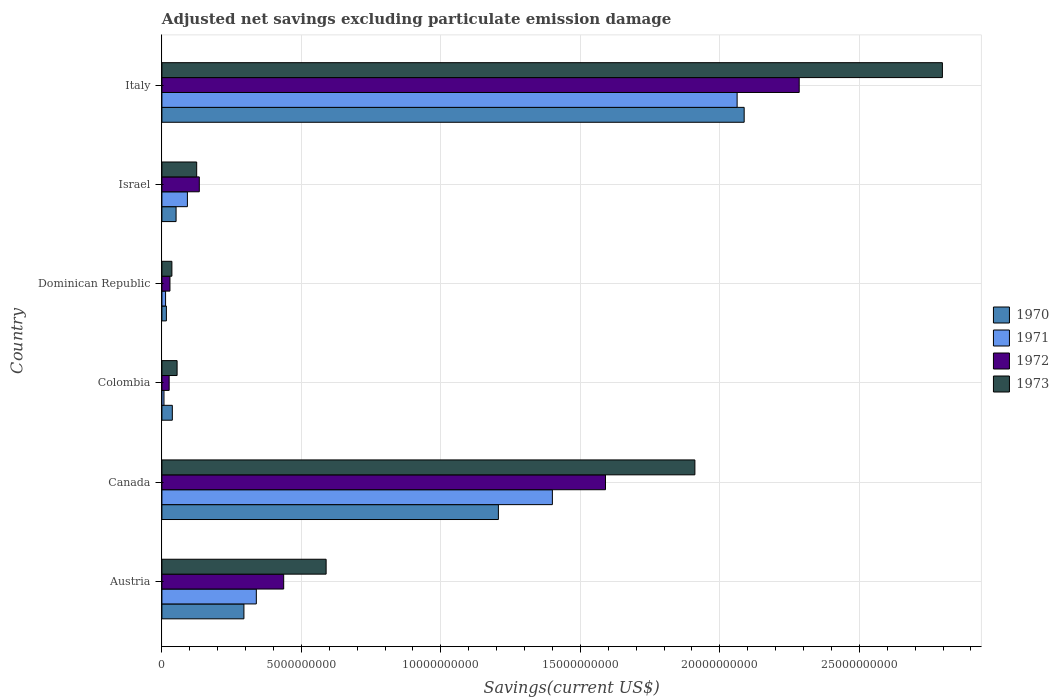How many groups of bars are there?
Provide a succinct answer. 6. Are the number of bars on each tick of the Y-axis equal?
Offer a very short reply. Yes. How many bars are there on the 6th tick from the bottom?
Ensure brevity in your answer.  4. What is the adjusted net savings in 1970 in Austria?
Offer a very short reply. 2.94e+09. Across all countries, what is the maximum adjusted net savings in 1970?
Offer a very short reply. 2.09e+1. Across all countries, what is the minimum adjusted net savings in 1973?
Keep it short and to the point. 3.58e+08. In which country was the adjusted net savings in 1970 minimum?
Your response must be concise. Dominican Republic. What is the total adjusted net savings in 1973 in the graph?
Your response must be concise. 5.51e+1. What is the difference between the adjusted net savings in 1971 in Austria and that in Israel?
Offer a terse response. 2.47e+09. What is the difference between the adjusted net savings in 1970 in Colombia and the adjusted net savings in 1972 in Canada?
Offer a terse response. -1.55e+1. What is the average adjusted net savings in 1972 per country?
Make the answer very short. 7.50e+09. What is the difference between the adjusted net savings in 1971 and adjusted net savings in 1972 in Israel?
Your answer should be very brief. -4.27e+08. In how many countries, is the adjusted net savings in 1972 greater than 15000000000 US$?
Offer a very short reply. 2. What is the ratio of the adjusted net savings in 1970 in Canada to that in Israel?
Make the answer very short. 23.75. What is the difference between the highest and the second highest adjusted net savings in 1973?
Offer a terse response. 8.87e+09. What is the difference between the highest and the lowest adjusted net savings in 1971?
Offer a very short reply. 2.05e+1. Is it the case that in every country, the sum of the adjusted net savings in 1970 and adjusted net savings in 1973 is greater than the sum of adjusted net savings in 1972 and adjusted net savings in 1971?
Provide a short and direct response. No. What does the 2nd bar from the top in Dominican Republic represents?
Provide a short and direct response. 1972. What does the 1st bar from the bottom in Colombia represents?
Give a very brief answer. 1970. Is it the case that in every country, the sum of the adjusted net savings in 1973 and adjusted net savings in 1972 is greater than the adjusted net savings in 1970?
Provide a succinct answer. Yes. Are all the bars in the graph horizontal?
Offer a very short reply. Yes. How many countries are there in the graph?
Provide a short and direct response. 6. What is the difference between two consecutive major ticks on the X-axis?
Your response must be concise. 5.00e+09. Does the graph contain any zero values?
Make the answer very short. No. Where does the legend appear in the graph?
Your answer should be very brief. Center right. What is the title of the graph?
Keep it short and to the point. Adjusted net savings excluding particulate emission damage. What is the label or title of the X-axis?
Your answer should be very brief. Savings(current US$). What is the label or title of the Y-axis?
Your response must be concise. Country. What is the Savings(current US$) of 1970 in Austria?
Keep it short and to the point. 2.94e+09. What is the Savings(current US$) in 1971 in Austria?
Ensure brevity in your answer.  3.38e+09. What is the Savings(current US$) in 1972 in Austria?
Provide a succinct answer. 4.37e+09. What is the Savings(current US$) in 1973 in Austria?
Your answer should be very brief. 5.89e+09. What is the Savings(current US$) of 1970 in Canada?
Offer a terse response. 1.21e+1. What is the Savings(current US$) in 1971 in Canada?
Offer a very short reply. 1.40e+1. What is the Savings(current US$) of 1972 in Canada?
Your response must be concise. 1.59e+1. What is the Savings(current US$) in 1973 in Canada?
Your response must be concise. 1.91e+1. What is the Savings(current US$) of 1970 in Colombia?
Ensure brevity in your answer.  3.74e+08. What is the Savings(current US$) in 1971 in Colombia?
Provide a succinct answer. 7.46e+07. What is the Savings(current US$) in 1972 in Colombia?
Your answer should be very brief. 2.60e+08. What is the Savings(current US$) of 1973 in Colombia?
Provide a succinct answer. 5.45e+08. What is the Savings(current US$) of 1970 in Dominican Republic?
Keep it short and to the point. 1.61e+08. What is the Savings(current US$) in 1971 in Dominican Republic?
Provide a short and direct response. 1.32e+08. What is the Savings(current US$) in 1972 in Dominican Republic?
Your answer should be very brief. 2.89e+08. What is the Savings(current US$) of 1973 in Dominican Republic?
Offer a very short reply. 3.58e+08. What is the Savings(current US$) of 1970 in Israel?
Offer a terse response. 5.08e+08. What is the Savings(current US$) in 1971 in Israel?
Offer a terse response. 9.14e+08. What is the Savings(current US$) of 1972 in Israel?
Your answer should be very brief. 1.34e+09. What is the Savings(current US$) of 1973 in Israel?
Your response must be concise. 1.25e+09. What is the Savings(current US$) in 1970 in Italy?
Your answer should be compact. 2.09e+1. What is the Savings(current US$) of 1971 in Italy?
Offer a terse response. 2.06e+1. What is the Savings(current US$) of 1972 in Italy?
Offer a terse response. 2.28e+1. What is the Savings(current US$) in 1973 in Italy?
Make the answer very short. 2.80e+1. Across all countries, what is the maximum Savings(current US$) of 1970?
Provide a succinct answer. 2.09e+1. Across all countries, what is the maximum Savings(current US$) in 1971?
Ensure brevity in your answer.  2.06e+1. Across all countries, what is the maximum Savings(current US$) of 1972?
Make the answer very short. 2.28e+1. Across all countries, what is the maximum Savings(current US$) of 1973?
Give a very brief answer. 2.80e+1. Across all countries, what is the minimum Savings(current US$) in 1970?
Offer a very short reply. 1.61e+08. Across all countries, what is the minimum Savings(current US$) in 1971?
Provide a short and direct response. 7.46e+07. Across all countries, what is the minimum Savings(current US$) in 1972?
Your answer should be very brief. 2.60e+08. Across all countries, what is the minimum Savings(current US$) of 1973?
Your answer should be compact. 3.58e+08. What is the total Savings(current US$) of 1970 in the graph?
Make the answer very short. 3.69e+1. What is the total Savings(current US$) in 1971 in the graph?
Offer a very short reply. 3.91e+1. What is the total Savings(current US$) of 1972 in the graph?
Offer a very short reply. 4.50e+1. What is the total Savings(current US$) in 1973 in the graph?
Ensure brevity in your answer.  5.51e+1. What is the difference between the Savings(current US$) in 1970 in Austria and that in Canada?
Offer a terse response. -9.12e+09. What is the difference between the Savings(current US$) of 1971 in Austria and that in Canada?
Make the answer very short. -1.06e+1. What is the difference between the Savings(current US$) of 1972 in Austria and that in Canada?
Provide a succinct answer. -1.15e+1. What is the difference between the Savings(current US$) of 1973 in Austria and that in Canada?
Your answer should be very brief. -1.32e+1. What is the difference between the Savings(current US$) of 1970 in Austria and that in Colombia?
Make the answer very short. 2.57e+09. What is the difference between the Savings(current US$) in 1971 in Austria and that in Colombia?
Provide a short and direct response. 3.31e+09. What is the difference between the Savings(current US$) of 1972 in Austria and that in Colombia?
Provide a succinct answer. 4.11e+09. What is the difference between the Savings(current US$) of 1973 in Austria and that in Colombia?
Provide a short and direct response. 5.34e+09. What is the difference between the Savings(current US$) in 1970 in Austria and that in Dominican Republic?
Offer a very short reply. 2.78e+09. What is the difference between the Savings(current US$) of 1971 in Austria and that in Dominican Republic?
Provide a succinct answer. 3.25e+09. What is the difference between the Savings(current US$) of 1972 in Austria and that in Dominican Republic?
Your response must be concise. 4.08e+09. What is the difference between the Savings(current US$) of 1973 in Austria and that in Dominican Republic?
Make the answer very short. 5.53e+09. What is the difference between the Savings(current US$) in 1970 in Austria and that in Israel?
Provide a succinct answer. 2.43e+09. What is the difference between the Savings(current US$) in 1971 in Austria and that in Israel?
Your answer should be very brief. 2.47e+09. What is the difference between the Savings(current US$) of 1972 in Austria and that in Israel?
Provide a short and direct response. 3.02e+09. What is the difference between the Savings(current US$) of 1973 in Austria and that in Israel?
Your response must be concise. 4.64e+09. What is the difference between the Savings(current US$) in 1970 in Austria and that in Italy?
Ensure brevity in your answer.  -1.79e+1. What is the difference between the Savings(current US$) of 1971 in Austria and that in Italy?
Keep it short and to the point. -1.72e+1. What is the difference between the Savings(current US$) in 1972 in Austria and that in Italy?
Offer a very short reply. -1.85e+1. What is the difference between the Savings(current US$) of 1973 in Austria and that in Italy?
Your response must be concise. -2.21e+1. What is the difference between the Savings(current US$) in 1970 in Canada and that in Colombia?
Offer a very short reply. 1.17e+1. What is the difference between the Savings(current US$) in 1971 in Canada and that in Colombia?
Keep it short and to the point. 1.39e+1. What is the difference between the Savings(current US$) of 1972 in Canada and that in Colombia?
Keep it short and to the point. 1.56e+1. What is the difference between the Savings(current US$) of 1973 in Canada and that in Colombia?
Offer a very short reply. 1.86e+1. What is the difference between the Savings(current US$) of 1970 in Canada and that in Dominican Republic?
Offer a very short reply. 1.19e+1. What is the difference between the Savings(current US$) in 1971 in Canada and that in Dominican Republic?
Provide a short and direct response. 1.39e+1. What is the difference between the Savings(current US$) of 1972 in Canada and that in Dominican Republic?
Ensure brevity in your answer.  1.56e+1. What is the difference between the Savings(current US$) of 1973 in Canada and that in Dominican Republic?
Keep it short and to the point. 1.87e+1. What is the difference between the Savings(current US$) of 1970 in Canada and that in Israel?
Your answer should be compact. 1.16e+1. What is the difference between the Savings(current US$) of 1971 in Canada and that in Israel?
Ensure brevity in your answer.  1.31e+1. What is the difference between the Savings(current US$) in 1972 in Canada and that in Israel?
Keep it short and to the point. 1.46e+1. What is the difference between the Savings(current US$) of 1973 in Canada and that in Israel?
Offer a terse response. 1.79e+1. What is the difference between the Savings(current US$) in 1970 in Canada and that in Italy?
Keep it short and to the point. -8.81e+09. What is the difference between the Savings(current US$) of 1971 in Canada and that in Italy?
Provide a succinct answer. -6.62e+09. What is the difference between the Savings(current US$) in 1972 in Canada and that in Italy?
Your answer should be very brief. -6.94e+09. What is the difference between the Savings(current US$) in 1973 in Canada and that in Italy?
Your answer should be very brief. -8.87e+09. What is the difference between the Savings(current US$) in 1970 in Colombia and that in Dominican Republic?
Your response must be concise. 2.13e+08. What is the difference between the Savings(current US$) in 1971 in Colombia and that in Dominican Republic?
Ensure brevity in your answer.  -5.69e+07. What is the difference between the Savings(current US$) in 1972 in Colombia and that in Dominican Republic?
Provide a succinct answer. -2.84e+07. What is the difference between the Savings(current US$) in 1973 in Colombia and that in Dominican Republic?
Provide a short and direct response. 1.87e+08. What is the difference between the Savings(current US$) in 1970 in Colombia and that in Israel?
Offer a terse response. -1.34e+08. What is the difference between the Savings(current US$) of 1971 in Colombia and that in Israel?
Offer a terse response. -8.40e+08. What is the difference between the Savings(current US$) in 1972 in Colombia and that in Israel?
Offer a terse response. -1.08e+09. What is the difference between the Savings(current US$) of 1973 in Colombia and that in Israel?
Offer a very short reply. -7.02e+08. What is the difference between the Savings(current US$) in 1970 in Colombia and that in Italy?
Your answer should be very brief. -2.05e+1. What is the difference between the Savings(current US$) in 1971 in Colombia and that in Italy?
Give a very brief answer. -2.05e+1. What is the difference between the Savings(current US$) of 1972 in Colombia and that in Italy?
Your answer should be compact. -2.26e+1. What is the difference between the Savings(current US$) in 1973 in Colombia and that in Italy?
Offer a terse response. -2.74e+1. What is the difference between the Savings(current US$) of 1970 in Dominican Republic and that in Israel?
Provide a short and direct response. -3.47e+08. What is the difference between the Savings(current US$) in 1971 in Dominican Republic and that in Israel?
Offer a terse response. -7.83e+08. What is the difference between the Savings(current US$) of 1972 in Dominican Republic and that in Israel?
Keep it short and to the point. -1.05e+09. What is the difference between the Savings(current US$) in 1973 in Dominican Republic and that in Israel?
Make the answer very short. -8.89e+08. What is the difference between the Savings(current US$) in 1970 in Dominican Republic and that in Italy?
Offer a very short reply. -2.07e+1. What is the difference between the Savings(current US$) in 1971 in Dominican Republic and that in Italy?
Ensure brevity in your answer.  -2.05e+1. What is the difference between the Savings(current US$) in 1972 in Dominican Republic and that in Italy?
Your answer should be compact. -2.26e+1. What is the difference between the Savings(current US$) in 1973 in Dominican Republic and that in Italy?
Offer a very short reply. -2.76e+1. What is the difference between the Savings(current US$) in 1970 in Israel and that in Italy?
Provide a succinct answer. -2.04e+1. What is the difference between the Savings(current US$) of 1971 in Israel and that in Italy?
Make the answer very short. -1.97e+1. What is the difference between the Savings(current US$) of 1972 in Israel and that in Italy?
Give a very brief answer. -2.15e+1. What is the difference between the Savings(current US$) of 1973 in Israel and that in Italy?
Your answer should be very brief. -2.67e+1. What is the difference between the Savings(current US$) in 1970 in Austria and the Savings(current US$) in 1971 in Canada?
Give a very brief answer. -1.11e+1. What is the difference between the Savings(current US$) in 1970 in Austria and the Savings(current US$) in 1972 in Canada?
Offer a terse response. -1.30e+1. What is the difference between the Savings(current US$) in 1970 in Austria and the Savings(current US$) in 1973 in Canada?
Make the answer very short. -1.62e+1. What is the difference between the Savings(current US$) of 1971 in Austria and the Savings(current US$) of 1972 in Canada?
Provide a succinct answer. -1.25e+1. What is the difference between the Savings(current US$) of 1971 in Austria and the Savings(current US$) of 1973 in Canada?
Provide a short and direct response. -1.57e+1. What is the difference between the Savings(current US$) of 1972 in Austria and the Savings(current US$) of 1973 in Canada?
Give a very brief answer. -1.47e+1. What is the difference between the Savings(current US$) in 1970 in Austria and the Savings(current US$) in 1971 in Colombia?
Keep it short and to the point. 2.87e+09. What is the difference between the Savings(current US$) in 1970 in Austria and the Savings(current US$) in 1972 in Colombia?
Give a very brief answer. 2.68e+09. What is the difference between the Savings(current US$) of 1970 in Austria and the Savings(current US$) of 1973 in Colombia?
Keep it short and to the point. 2.40e+09. What is the difference between the Savings(current US$) in 1971 in Austria and the Savings(current US$) in 1972 in Colombia?
Provide a short and direct response. 3.12e+09. What is the difference between the Savings(current US$) in 1971 in Austria and the Savings(current US$) in 1973 in Colombia?
Provide a short and direct response. 2.84e+09. What is the difference between the Savings(current US$) of 1972 in Austria and the Savings(current US$) of 1973 in Colombia?
Provide a short and direct response. 3.82e+09. What is the difference between the Savings(current US$) in 1970 in Austria and the Savings(current US$) in 1971 in Dominican Republic?
Offer a terse response. 2.81e+09. What is the difference between the Savings(current US$) in 1970 in Austria and the Savings(current US$) in 1972 in Dominican Republic?
Your response must be concise. 2.65e+09. What is the difference between the Savings(current US$) of 1970 in Austria and the Savings(current US$) of 1973 in Dominican Republic?
Provide a short and direct response. 2.58e+09. What is the difference between the Savings(current US$) of 1971 in Austria and the Savings(current US$) of 1972 in Dominican Republic?
Provide a short and direct response. 3.10e+09. What is the difference between the Savings(current US$) of 1971 in Austria and the Savings(current US$) of 1973 in Dominican Republic?
Your answer should be very brief. 3.03e+09. What is the difference between the Savings(current US$) in 1972 in Austria and the Savings(current US$) in 1973 in Dominican Republic?
Keep it short and to the point. 4.01e+09. What is the difference between the Savings(current US$) of 1970 in Austria and the Savings(current US$) of 1971 in Israel?
Your answer should be very brief. 2.03e+09. What is the difference between the Savings(current US$) in 1970 in Austria and the Savings(current US$) in 1972 in Israel?
Offer a very short reply. 1.60e+09. What is the difference between the Savings(current US$) of 1970 in Austria and the Savings(current US$) of 1973 in Israel?
Provide a succinct answer. 1.69e+09. What is the difference between the Savings(current US$) in 1971 in Austria and the Savings(current US$) in 1972 in Israel?
Provide a short and direct response. 2.04e+09. What is the difference between the Savings(current US$) of 1971 in Austria and the Savings(current US$) of 1973 in Israel?
Keep it short and to the point. 2.14e+09. What is the difference between the Savings(current US$) of 1972 in Austria and the Savings(current US$) of 1973 in Israel?
Your answer should be very brief. 3.12e+09. What is the difference between the Savings(current US$) in 1970 in Austria and the Savings(current US$) in 1971 in Italy?
Ensure brevity in your answer.  -1.77e+1. What is the difference between the Savings(current US$) in 1970 in Austria and the Savings(current US$) in 1972 in Italy?
Give a very brief answer. -1.99e+1. What is the difference between the Savings(current US$) of 1970 in Austria and the Savings(current US$) of 1973 in Italy?
Ensure brevity in your answer.  -2.50e+1. What is the difference between the Savings(current US$) of 1971 in Austria and the Savings(current US$) of 1972 in Italy?
Offer a terse response. -1.95e+1. What is the difference between the Savings(current US$) in 1971 in Austria and the Savings(current US$) in 1973 in Italy?
Offer a terse response. -2.46e+1. What is the difference between the Savings(current US$) in 1972 in Austria and the Savings(current US$) in 1973 in Italy?
Your response must be concise. -2.36e+1. What is the difference between the Savings(current US$) in 1970 in Canada and the Savings(current US$) in 1971 in Colombia?
Make the answer very short. 1.20e+1. What is the difference between the Savings(current US$) in 1970 in Canada and the Savings(current US$) in 1972 in Colombia?
Offer a very short reply. 1.18e+1. What is the difference between the Savings(current US$) of 1970 in Canada and the Savings(current US$) of 1973 in Colombia?
Your response must be concise. 1.15e+1. What is the difference between the Savings(current US$) of 1971 in Canada and the Savings(current US$) of 1972 in Colombia?
Offer a terse response. 1.37e+1. What is the difference between the Savings(current US$) of 1971 in Canada and the Savings(current US$) of 1973 in Colombia?
Provide a short and direct response. 1.35e+1. What is the difference between the Savings(current US$) of 1972 in Canada and the Savings(current US$) of 1973 in Colombia?
Ensure brevity in your answer.  1.54e+1. What is the difference between the Savings(current US$) in 1970 in Canada and the Savings(current US$) in 1971 in Dominican Republic?
Provide a succinct answer. 1.19e+1. What is the difference between the Savings(current US$) of 1970 in Canada and the Savings(current US$) of 1972 in Dominican Republic?
Ensure brevity in your answer.  1.18e+1. What is the difference between the Savings(current US$) in 1970 in Canada and the Savings(current US$) in 1973 in Dominican Republic?
Provide a short and direct response. 1.17e+1. What is the difference between the Savings(current US$) of 1971 in Canada and the Savings(current US$) of 1972 in Dominican Republic?
Your response must be concise. 1.37e+1. What is the difference between the Savings(current US$) in 1971 in Canada and the Savings(current US$) in 1973 in Dominican Republic?
Give a very brief answer. 1.36e+1. What is the difference between the Savings(current US$) of 1972 in Canada and the Savings(current US$) of 1973 in Dominican Republic?
Offer a terse response. 1.55e+1. What is the difference between the Savings(current US$) of 1970 in Canada and the Savings(current US$) of 1971 in Israel?
Make the answer very short. 1.11e+1. What is the difference between the Savings(current US$) in 1970 in Canada and the Savings(current US$) in 1972 in Israel?
Your answer should be very brief. 1.07e+1. What is the difference between the Savings(current US$) of 1970 in Canada and the Savings(current US$) of 1973 in Israel?
Your answer should be very brief. 1.08e+1. What is the difference between the Savings(current US$) in 1971 in Canada and the Savings(current US$) in 1972 in Israel?
Give a very brief answer. 1.27e+1. What is the difference between the Savings(current US$) in 1971 in Canada and the Savings(current US$) in 1973 in Israel?
Your answer should be compact. 1.27e+1. What is the difference between the Savings(current US$) of 1972 in Canada and the Savings(current US$) of 1973 in Israel?
Give a very brief answer. 1.47e+1. What is the difference between the Savings(current US$) in 1970 in Canada and the Savings(current US$) in 1971 in Italy?
Give a very brief answer. -8.56e+09. What is the difference between the Savings(current US$) in 1970 in Canada and the Savings(current US$) in 1972 in Italy?
Your response must be concise. -1.08e+1. What is the difference between the Savings(current US$) of 1970 in Canada and the Savings(current US$) of 1973 in Italy?
Give a very brief answer. -1.59e+1. What is the difference between the Savings(current US$) of 1971 in Canada and the Savings(current US$) of 1972 in Italy?
Your answer should be very brief. -8.85e+09. What is the difference between the Savings(current US$) of 1971 in Canada and the Savings(current US$) of 1973 in Italy?
Your response must be concise. -1.40e+1. What is the difference between the Savings(current US$) in 1972 in Canada and the Savings(current US$) in 1973 in Italy?
Provide a succinct answer. -1.21e+1. What is the difference between the Savings(current US$) in 1970 in Colombia and the Savings(current US$) in 1971 in Dominican Republic?
Keep it short and to the point. 2.42e+08. What is the difference between the Savings(current US$) in 1970 in Colombia and the Savings(current US$) in 1972 in Dominican Republic?
Provide a short and direct response. 8.52e+07. What is the difference between the Savings(current US$) in 1970 in Colombia and the Savings(current US$) in 1973 in Dominican Republic?
Give a very brief answer. 1.57e+07. What is the difference between the Savings(current US$) in 1971 in Colombia and the Savings(current US$) in 1972 in Dominican Republic?
Make the answer very short. -2.14e+08. What is the difference between the Savings(current US$) of 1971 in Colombia and the Savings(current US$) of 1973 in Dominican Republic?
Ensure brevity in your answer.  -2.84e+08. What is the difference between the Savings(current US$) in 1972 in Colombia and the Savings(current US$) in 1973 in Dominican Republic?
Keep it short and to the point. -9.79e+07. What is the difference between the Savings(current US$) of 1970 in Colombia and the Savings(current US$) of 1971 in Israel?
Your response must be concise. -5.40e+08. What is the difference between the Savings(current US$) of 1970 in Colombia and the Savings(current US$) of 1972 in Israel?
Offer a terse response. -9.67e+08. What is the difference between the Savings(current US$) of 1970 in Colombia and the Savings(current US$) of 1973 in Israel?
Your answer should be very brief. -8.73e+08. What is the difference between the Savings(current US$) of 1971 in Colombia and the Savings(current US$) of 1972 in Israel?
Ensure brevity in your answer.  -1.27e+09. What is the difference between the Savings(current US$) of 1971 in Colombia and the Savings(current US$) of 1973 in Israel?
Provide a short and direct response. -1.17e+09. What is the difference between the Savings(current US$) in 1972 in Colombia and the Savings(current US$) in 1973 in Israel?
Your answer should be compact. -9.87e+08. What is the difference between the Savings(current US$) in 1970 in Colombia and the Savings(current US$) in 1971 in Italy?
Your response must be concise. -2.02e+1. What is the difference between the Savings(current US$) of 1970 in Colombia and the Savings(current US$) of 1972 in Italy?
Provide a succinct answer. -2.25e+1. What is the difference between the Savings(current US$) in 1970 in Colombia and the Savings(current US$) in 1973 in Italy?
Provide a succinct answer. -2.76e+1. What is the difference between the Savings(current US$) in 1971 in Colombia and the Savings(current US$) in 1972 in Italy?
Your answer should be compact. -2.28e+1. What is the difference between the Savings(current US$) of 1971 in Colombia and the Savings(current US$) of 1973 in Italy?
Provide a succinct answer. -2.79e+1. What is the difference between the Savings(current US$) in 1972 in Colombia and the Savings(current US$) in 1973 in Italy?
Provide a succinct answer. -2.77e+1. What is the difference between the Savings(current US$) in 1970 in Dominican Republic and the Savings(current US$) in 1971 in Israel?
Provide a short and direct response. -7.53e+08. What is the difference between the Savings(current US$) in 1970 in Dominican Republic and the Savings(current US$) in 1972 in Israel?
Make the answer very short. -1.18e+09. What is the difference between the Savings(current US$) of 1970 in Dominican Republic and the Savings(current US$) of 1973 in Israel?
Offer a very short reply. -1.09e+09. What is the difference between the Savings(current US$) in 1971 in Dominican Republic and the Savings(current US$) in 1972 in Israel?
Make the answer very short. -1.21e+09. What is the difference between the Savings(current US$) of 1971 in Dominican Republic and the Savings(current US$) of 1973 in Israel?
Keep it short and to the point. -1.12e+09. What is the difference between the Savings(current US$) of 1972 in Dominican Republic and the Savings(current US$) of 1973 in Israel?
Offer a very short reply. -9.58e+08. What is the difference between the Savings(current US$) of 1970 in Dominican Republic and the Savings(current US$) of 1971 in Italy?
Your answer should be compact. -2.05e+1. What is the difference between the Savings(current US$) of 1970 in Dominican Republic and the Savings(current US$) of 1972 in Italy?
Make the answer very short. -2.27e+1. What is the difference between the Savings(current US$) in 1970 in Dominican Republic and the Savings(current US$) in 1973 in Italy?
Keep it short and to the point. -2.78e+1. What is the difference between the Savings(current US$) in 1971 in Dominican Republic and the Savings(current US$) in 1972 in Italy?
Your answer should be compact. -2.27e+1. What is the difference between the Savings(current US$) of 1971 in Dominican Republic and the Savings(current US$) of 1973 in Italy?
Your answer should be very brief. -2.78e+1. What is the difference between the Savings(current US$) of 1972 in Dominican Republic and the Savings(current US$) of 1973 in Italy?
Your response must be concise. -2.77e+1. What is the difference between the Savings(current US$) in 1970 in Israel and the Savings(current US$) in 1971 in Italy?
Make the answer very short. -2.01e+1. What is the difference between the Savings(current US$) in 1970 in Israel and the Savings(current US$) in 1972 in Italy?
Your response must be concise. -2.23e+1. What is the difference between the Savings(current US$) in 1970 in Israel and the Savings(current US$) in 1973 in Italy?
Offer a terse response. -2.75e+1. What is the difference between the Savings(current US$) of 1971 in Israel and the Savings(current US$) of 1972 in Italy?
Keep it short and to the point. -2.19e+1. What is the difference between the Savings(current US$) of 1971 in Israel and the Savings(current US$) of 1973 in Italy?
Your answer should be compact. -2.71e+1. What is the difference between the Savings(current US$) of 1972 in Israel and the Savings(current US$) of 1973 in Italy?
Give a very brief answer. -2.66e+1. What is the average Savings(current US$) of 1970 per country?
Your answer should be compact. 6.15e+09. What is the average Savings(current US$) of 1971 per country?
Your answer should be compact. 6.52e+09. What is the average Savings(current US$) in 1972 per country?
Offer a very short reply. 7.50e+09. What is the average Savings(current US$) in 1973 per country?
Provide a short and direct response. 9.19e+09. What is the difference between the Savings(current US$) in 1970 and Savings(current US$) in 1971 in Austria?
Your response must be concise. -4.45e+08. What is the difference between the Savings(current US$) of 1970 and Savings(current US$) of 1972 in Austria?
Offer a terse response. -1.43e+09. What is the difference between the Savings(current US$) of 1970 and Savings(current US$) of 1973 in Austria?
Provide a succinct answer. -2.95e+09. What is the difference between the Savings(current US$) of 1971 and Savings(current US$) of 1972 in Austria?
Make the answer very short. -9.81e+08. What is the difference between the Savings(current US$) in 1971 and Savings(current US$) in 1973 in Austria?
Your answer should be very brief. -2.50e+09. What is the difference between the Savings(current US$) in 1972 and Savings(current US$) in 1973 in Austria?
Provide a short and direct response. -1.52e+09. What is the difference between the Savings(current US$) of 1970 and Savings(current US$) of 1971 in Canada?
Give a very brief answer. -1.94e+09. What is the difference between the Savings(current US$) of 1970 and Savings(current US$) of 1972 in Canada?
Offer a terse response. -3.84e+09. What is the difference between the Savings(current US$) in 1970 and Savings(current US$) in 1973 in Canada?
Offer a terse response. -7.04e+09. What is the difference between the Savings(current US$) of 1971 and Savings(current US$) of 1972 in Canada?
Your answer should be very brief. -1.90e+09. What is the difference between the Savings(current US$) in 1971 and Savings(current US$) in 1973 in Canada?
Give a very brief answer. -5.11e+09. What is the difference between the Savings(current US$) in 1972 and Savings(current US$) in 1973 in Canada?
Your answer should be compact. -3.20e+09. What is the difference between the Savings(current US$) of 1970 and Savings(current US$) of 1971 in Colombia?
Your response must be concise. 2.99e+08. What is the difference between the Savings(current US$) in 1970 and Savings(current US$) in 1972 in Colombia?
Ensure brevity in your answer.  1.14e+08. What is the difference between the Savings(current US$) in 1970 and Savings(current US$) in 1973 in Colombia?
Offer a very short reply. -1.71e+08. What is the difference between the Savings(current US$) of 1971 and Savings(current US$) of 1972 in Colombia?
Offer a very short reply. -1.86e+08. What is the difference between the Savings(current US$) of 1971 and Savings(current US$) of 1973 in Colombia?
Provide a short and direct response. -4.70e+08. What is the difference between the Savings(current US$) of 1972 and Savings(current US$) of 1973 in Colombia?
Offer a terse response. -2.85e+08. What is the difference between the Savings(current US$) in 1970 and Savings(current US$) in 1971 in Dominican Republic?
Make the answer very short. 2.96e+07. What is the difference between the Savings(current US$) in 1970 and Savings(current US$) in 1972 in Dominican Republic?
Provide a short and direct response. -1.28e+08. What is the difference between the Savings(current US$) of 1970 and Savings(current US$) of 1973 in Dominican Republic?
Ensure brevity in your answer.  -1.97e+08. What is the difference between the Savings(current US$) of 1971 and Savings(current US$) of 1972 in Dominican Republic?
Provide a succinct answer. -1.57e+08. What is the difference between the Savings(current US$) of 1971 and Savings(current US$) of 1973 in Dominican Republic?
Your response must be concise. -2.27e+08. What is the difference between the Savings(current US$) in 1972 and Savings(current US$) in 1973 in Dominican Republic?
Give a very brief answer. -6.95e+07. What is the difference between the Savings(current US$) in 1970 and Savings(current US$) in 1971 in Israel?
Your response must be concise. -4.06e+08. What is the difference between the Savings(current US$) in 1970 and Savings(current US$) in 1972 in Israel?
Give a very brief answer. -8.33e+08. What is the difference between the Savings(current US$) in 1970 and Savings(current US$) in 1973 in Israel?
Give a very brief answer. -7.39e+08. What is the difference between the Savings(current US$) in 1971 and Savings(current US$) in 1972 in Israel?
Keep it short and to the point. -4.27e+08. What is the difference between the Savings(current US$) in 1971 and Savings(current US$) in 1973 in Israel?
Give a very brief answer. -3.33e+08. What is the difference between the Savings(current US$) of 1972 and Savings(current US$) of 1973 in Israel?
Offer a terse response. 9.40e+07. What is the difference between the Savings(current US$) in 1970 and Savings(current US$) in 1971 in Italy?
Provide a succinct answer. 2.53e+08. What is the difference between the Savings(current US$) in 1970 and Savings(current US$) in 1972 in Italy?
Make the answer very short. -1.97e+09. What is the difference between the Savings(current US$) in 1970 and Savings(current US$) in 1973 in Italy?
Keep it short and to the point. -7.11e+09. What is the difference between the Savings(current US$) of 1971 and Savings(current US$) of 1972 in Italy?
Offer a very short reply. -2.23e+09. What is the difference between the Savings(current US$) of 1971 and Savings(current US$) of 1973 in Italy?
Your response must be concise. -7.36e+09. What is the difference between the Savings(current US$) in 1972 and Savings(current US$) in 1973 in Italy?
Make the answer very short. -5.13e+09. What is the ratio of the Savings(current US$) in 1970 in Austria to that in Canada?
Keep it short and to the point. 0.24. What is the ratio of the Savings(current US$) in 1971 in Austria to that in Canada?
Give a very brief answer. 0.24. What is the ratio of the Savings(current US$) in 1972 in Austria to that in Canada?
Provide a succinct answer. 0.27. What is the ratio of the Savings(current US$) in 1973 in Austria to that in Canada?
Offer a terse response. 0.31. What is the ratio of the Savings(current US$) in 1970 in Austria to that in Colombia?
Give a very brief answer. 7.86. What is the ratio of the Savings(current US$) in 1971 in Austria to that in Colombia?
Provide a short and direct response. 45.37. What is the ratio of the Savings(current US$) in 1972 in Austria to that in Colombia?
Keep it short and to the point. 16.77. What is the ratio of the Savings(current US$) of 1973 in Austria to that in Colombia?
Offer a very short reply. 10.8. What is the ratio of the Savings(current US$) of 1970 in Austria to that in Dominican Republic?
Offer a very short reply. 18.25. What is the ratio of the Savings(current US$) in 1971 in Austria to that in Dominican Republic?
Your answer should be very brief. 25.73. What is the ratio of the Savings(current US$) in 1972 in Austria to that in Dominican Republic?
Your answer should be compact. 15.12. What is the ratio of the Savings(current US$) of 1973 in Austria to that in Dominican Republic?
Offer a very short reply. 16.43. What is the ratio of the Savings(current US$) in 1970 in Austria to that in Israel?
Keep it short and to the point. 5.79. What is the ratio of the Savings(current US$) in 1971 in Austria to that in Israel?
Make the answer very short. 3.7. What is the ratio of the Savings(current US$) of 1972 in Austria to that in Israel?
Your answer should be compact. 3.26. What is the ratio of the Savings(current US$) of 1973 in Austria to that in Israel?
Give a very brief answer. 4.72. What is the ratio of the Savings(current US$) in 1970 in Austria to that in Italy?
Offer a terse response. 0.14. What is the ratio of the Savings(current US$) of 1971 in Austria to that in Italy?
Keep it short and to the point. 0.16. What is the ratio of the Savings(current US$) in 1972 in Austria to that in Italy?
Give a very brief answer. 0.19. What is the ratio of the Savings(current US$) of 1973 in Austria to that in Italy?
Provide a succinct answer. 0.21. What is the ratio of the Savings(current US$) in 1970 in Canada to that in Colombia?
Give a very brief answer. 32.26. What is the ratio of the Savings(current US$) in 1971 in Canada to that in Colombia?
Offer a very short reply. 187.59. What is the ratio of the Savings(current US$) of 1972 in Canada to that in Colombia?
Offer a very short reply. 61.09. What is the ratio of the Savings(current US$) of 1973 in Canada to that in Colombia?
Give a very brief answer. 35.07. What is the ratio of the Savings(current US$) of 1970 in Canada to that in Dominican Republic?
Offer a terse response. 74.87. What is the ratio of the Savings(current US$) in 1971 in Canada to that in Dominican Republic?
Keep it short and to the point. 106.4. What is the ratio of the Savings(current US$) of 1972 in Canada to that in Dominican Republic?
Your response must be concise. 55.08. What is the ratio of the Savings(current US$) of 1973 in Canada to that in Dominican Republic?
Your answer should be very brief. 53.33. What is the ratio of the Savings(current US$) of 1970 in Canada to that in Israel?
Your response must be concise. 23.75. What is the ratio of the Savings(current US$) in 1971 in Canada to that in Israel?
Offer a terse response. 15.31. What is the ratio of the Savings(current US$) of 1972 in Canada to that in Israel?
Provide a succinct answer. 11.86. What is the ratio of the Savings(current US$) of 1973 in Canada to that in Israel?
Give a very brief answer. 15.32. What is the ratio of the Savings(current US$) of 1970 in Canada to that in Italy?
Offer a very short reply. 0.58. What is the ratio of the Savings(current US$) in 1971 in Canada to that in Italy?
Provide a succinct answer. 0.68. What is the ratio of the Savings(current US$) of 1972 in Canada to that in Italy?
Your answer should be compact. 0.7. What is the ratio of the Savings(current US$) of 1973 in Canada to that in Italy?
Make the answer very short. 0.68. What is the ratio of the Savings(current US$) of 1970 in Colombia to that in Dominican Republic?
Offer a very short reply. 2.32. What is the ratio of the Savings(current US$) of 1971 in Colombia to that in Dominican Republic?
Ensure brevity in your answer.  0.57. What is the ratio of the Savings(current US$) in 1972 in Colombia to that in Dominican Republic?
Provide a succinct answer. 0.9. What is the ratio of the Savings(current US$) of 1973 in Colombia to that in Dominican Republic?
Keep it short and to the point. 1.52. What is the ratio of the Savings(current US$) in 1970 in Colombia to that in Israel?
Your answer should be compact. 0.74. What is the ratio of the Savings(current US$) of 1971 in Colombia to that in Israel?
Your response must be concise. 0.08. What is the ratio of the Savings(current US$) of 1972 in Colombia to that in Israel?
Offer a very short reply. 0.19. What is the ratio of the Savings(current US$) of 1973 in Colombia to that in Israel?
Make the answer very short. 0.44. What is the ratio of the Savings(current US$) in 1970 in Colombia to that in Italy?
Offer a very short reply. 0.02. What is the ratio of the Savings(current US$) of 1971 in Colombia to that in Italy?
Ensure brevity in your answer.  0. What is the ratio of the Savings(current US$) of 1972 in Colombia to that in Italy?
Your response must be concise. 0.01. What is the ratio of the Savings(current US$) of 1973 in Colombia to that in Italy?
Give a very brief answer. 0.02. What is the ratio of the Savings(current US$) in 1970 in Dominican Republic to that in Israel?
Offer a terse response. 0.32. What is the ratio of the Savings(current US$) in 1971 in Dominican Republic to that in Israel?
Make the answer very short. 0.14. What is the ratio of the Savings(current US$) in 1972 in Dominican Republic to that in Israel?
Offer a terse response. 0.22. What is the ratio of the Savings(current US$) in 1973 in Dominican Republic to that in Israel?
Provide a succinct answer. 0.29. What is the ratio of the Savings(current US$) in 1970 in Dominican Republic to that in Italy?
Offer a very short reply. 0.01. What is the ratio of the Savings(current US$) in 1971 in Dominican Republic to that in Italy?
Make the answer very short. 0.01. What is the ratio of the Savings(current US$) of 1972 in Dominican Republic to that in Italy?
Provide a short and direct response. 0.01. What is the ratio of the Savings(current US$) in 1973 in Dominican Republic to that in Italy?
Make the answer very short. 0.01. What is the ratio of the Savings(current US$) of 1970 in Israel to that in Italy?
Provide a short and direct response. 0.02. What is the ratio of the Savings(current US$) of 1971 in Israel to that in Italy?
Your answer should be very brief. 0.04. What is the ratio of the Savings(current US$) in 1972 in Israel to that in Italy?
Keep it short and to the point. 0.06. What is the ratio of the Savings(current US$) of 1973 in Israel to that in Italy?
Your response must be concise. 0.04. What is the difference between the highest and the second highest Savings(current US$) in 1970?
Make the answer very short. 8.81e+09. What is the difference between the highest and the second highest Savings(current US$) in 1971?
Offer a very short reply. 6.62e+09. What is the difference between the highest and the second highest Savings(current US$) in 1972?
Give a very brief answer. 6.94e+09. What is the difference between the highest and the second highest Savings(current US$) in 1973?
Offer a terse response. 8.87e+09. What is the difference between the highest and the lowest Savings(current US$) in 1970?
Keep it short and to the point. 2.07e+1. What is the difference between the highest and the lowest Savings(current US$) of 1971?
Keep it short and to the point. 2.05e+1. What is the difference between the highest and the lowest Savings(current US$) in 1972?
Offer a very short reply. 2.26e+1. What is the difference between the highest and the lowest Savings(current US$) of 1973?
Your response must be concise. 2.76e+1. 